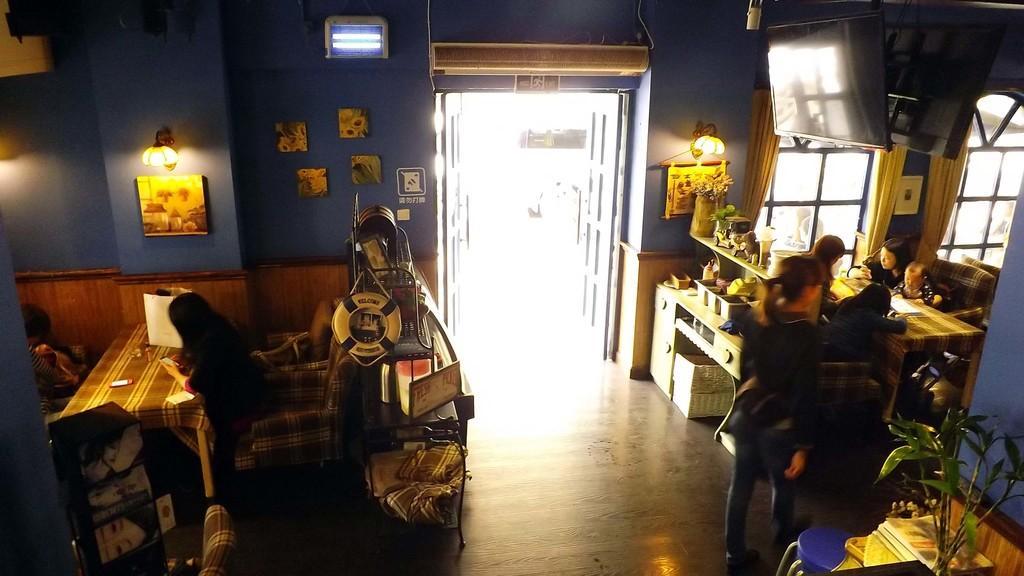Describe this image in one or two sentences. In this picture we can see there are some people sitting on chairs and a person is standing. On the floor there is a basket and cabinets and on the cabinets there are house plants and some items. Behind the people there is a wall with photo frames, lights, windows and a door. At the top there are televisions. 